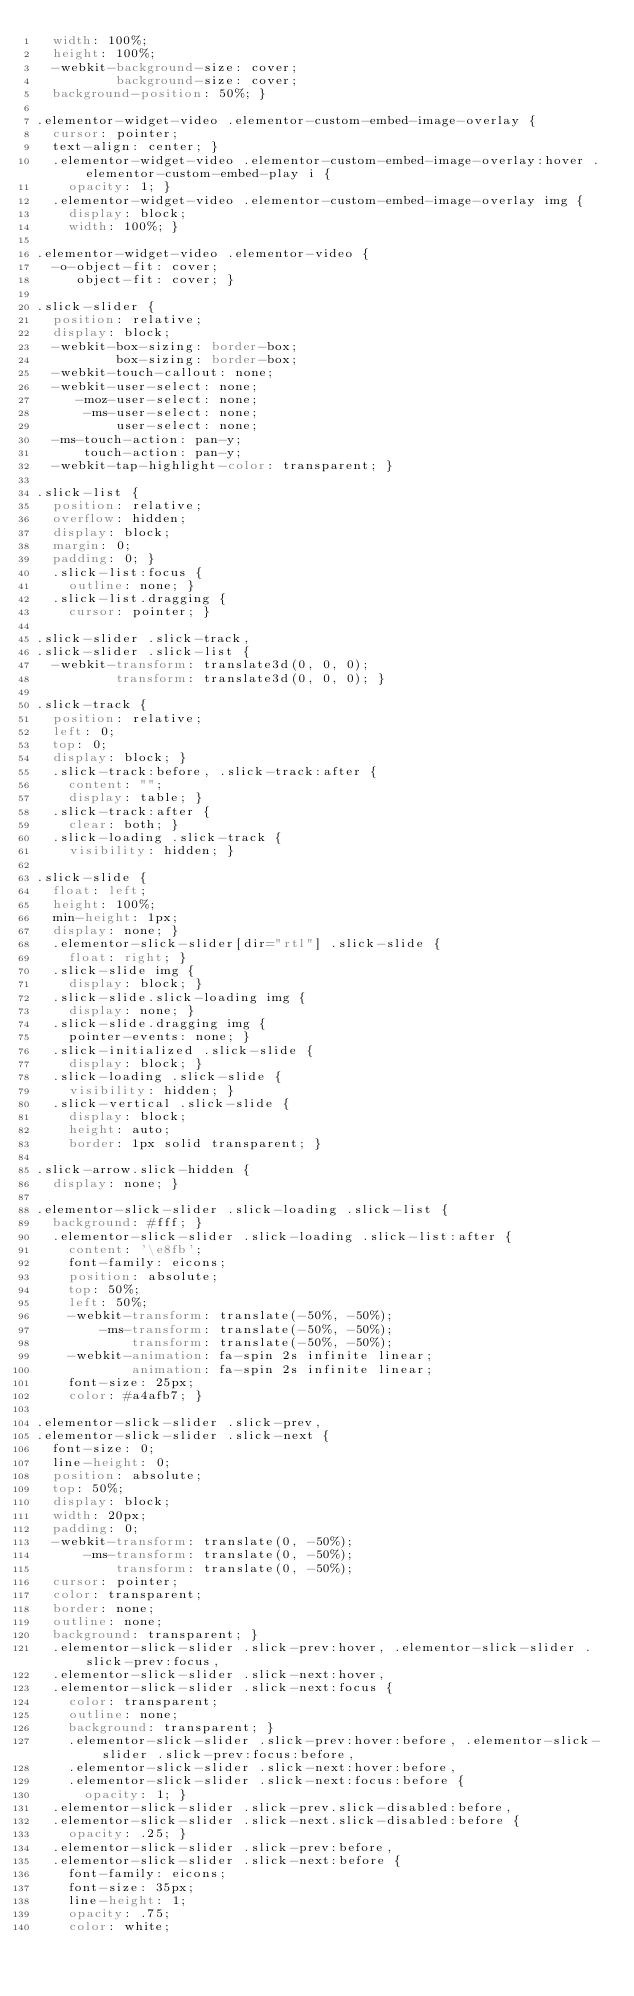<code> <loc_0><loc_0><loc_500><loc_500><_CSS_>  width: 100%;
  height: 100%;
  -webkit-background-size: cover;
          background-size: cover;
  background-position: 50%; }

.elementor-widget-video .elementor-custom-embed-image-overlay {
  cursor: pointer;
  text-align: center; }
  .elementor-widget-video .elementor-custom-embed-image-overlay:hover .elementor-custom-embed-play i {
    opacity: 1; }
  .elementor-widget-video .elementor-custom-embed-image-overlay img {
    display: block;
    width: 100%; }

.elementor-widget-video .elementor-video {
  -o-object-fit: cover;
     object-fit: cover; }

.slick-slider {
  position: relative;
  display: block;
  -webkit-box-sizing: border-box;
          box-sizing: border-box;
  -webkit-touch-callout: none;
  -webkit-user-select: none;
     -moz-user-select: none;
      -ms-user-select: none;
          user-select: none;
  -ms-touch-action: pan-y;
      touch-action: pan-y;
  -webkit-tap-highlight-color: transparent; }

.slick-list {
  position: relative;
  overflow: hidden;
  display: block;
  margin: 0;
  padding: 0; }
  .slick-list:focus {
    outline: none; }
  .slick-list.dragging {
    cursor: pointer; }

.slick-slider .slick-track,
.slick-slider .slick-list {
  -webkit-transform: translate3d(0, 0, 0);
          transform: translate3d(0, 0, 0); }

.slick-track {
  position: relative;
  left: 0;
  top: 0;
  display: block; }
  .slick-track:before, .slick-track:after {
    content: "";
    display: table; }
  .slick-track:after {
    clear: both; }
  .slick-loading .slick-track {
    visibility: hidden; }

.slick-slide {
  float: left;
  height: 100%;
  min-height: 1px;
  display: none; }
  .elementor-slick-slider[dir="rtl"] .slick-slide {
    float: right; }
  .slick-slide img {
    display: block; }
  .slick-slide.slick-loading img {
    display: none; }
  .slick-slide.dragging img {
    pointer-events: none; }
  .slick-initialized .slick-slide {
    display: block; }
  .slick-loading .slick-slide {
    visibility: hidden; }
  .slick-vertical .slick-slide {
    display: block;
    height: auto;
    border: 1px solid transparent; }

.slick-arrow.slick-hidden {
  display: none; }

.elementor-slick-slider .slick-loading .slick-list {
  background: #fff; }
  .elementor-slick-slider .slick-loading .slick-list:after {
    content: '\e8fb';
    font-family: eicons;
    position: absolute;
    top: 50%;
    left: 50%;
    -webkit-transform: translate(-50%, -50%);
        -ms-transform: translate(-50%, -50%);
            transform: translate(-50%, -50%);
    -webkit-animation: fa-spin 2s infinite linear;
            animation: fa-spin 2s infinite linear;
    font-size: 25px;
    color: #a4afb7; }

.elementor-slick-slider .slick-prev,
.elementor-slick-slider .slick-next {
  font-size: 0;
  line-height: 0;
  position: absolute;
  top: 50%;
  display: block;
  width: 20px;
  padding: 0;
  -webkit-transform: translate(0, -50%);
      -ms-transform: translate(0, -50%);
          transform: translate(0, -50%);
  cursor: pointer;
  color: transparent;
  border: none;
  outline: none;
  background: transparent; }
  .elementor-slick-slider .slick-prev:hover, .elementor-slick-slider .slick-prev:focus,
  .elementor-slick-slider .slick-next:hover,
  .elementor-slick-slider .slick-next:focus {
    color: transparent;
    outline: none;
    background: transparent; }
    .elementor-slick-slider .slick-prev:hover:before, .elementor-slick-slider .slick-prev:focus:before,
    .elementor-slick-slider .slick-next:hover:before,
    .elementor-slick-slider .slick-next:focus:before {
      opacity: 1; }
  .elementor-slick-slider .slick-prev.slick-disabled:before,
  .elementor-slick-slider .slick-next.slick-disabled:before {
    opacity: .25; }
  .elementor-slick-slider .slick-prev:before,
  .elementor-slick-slider .slick-next:before {
    font-family: eicons;
    font-size: 35px;
    line-height: 1;
    opacity: .75;
    color: white;</code> 